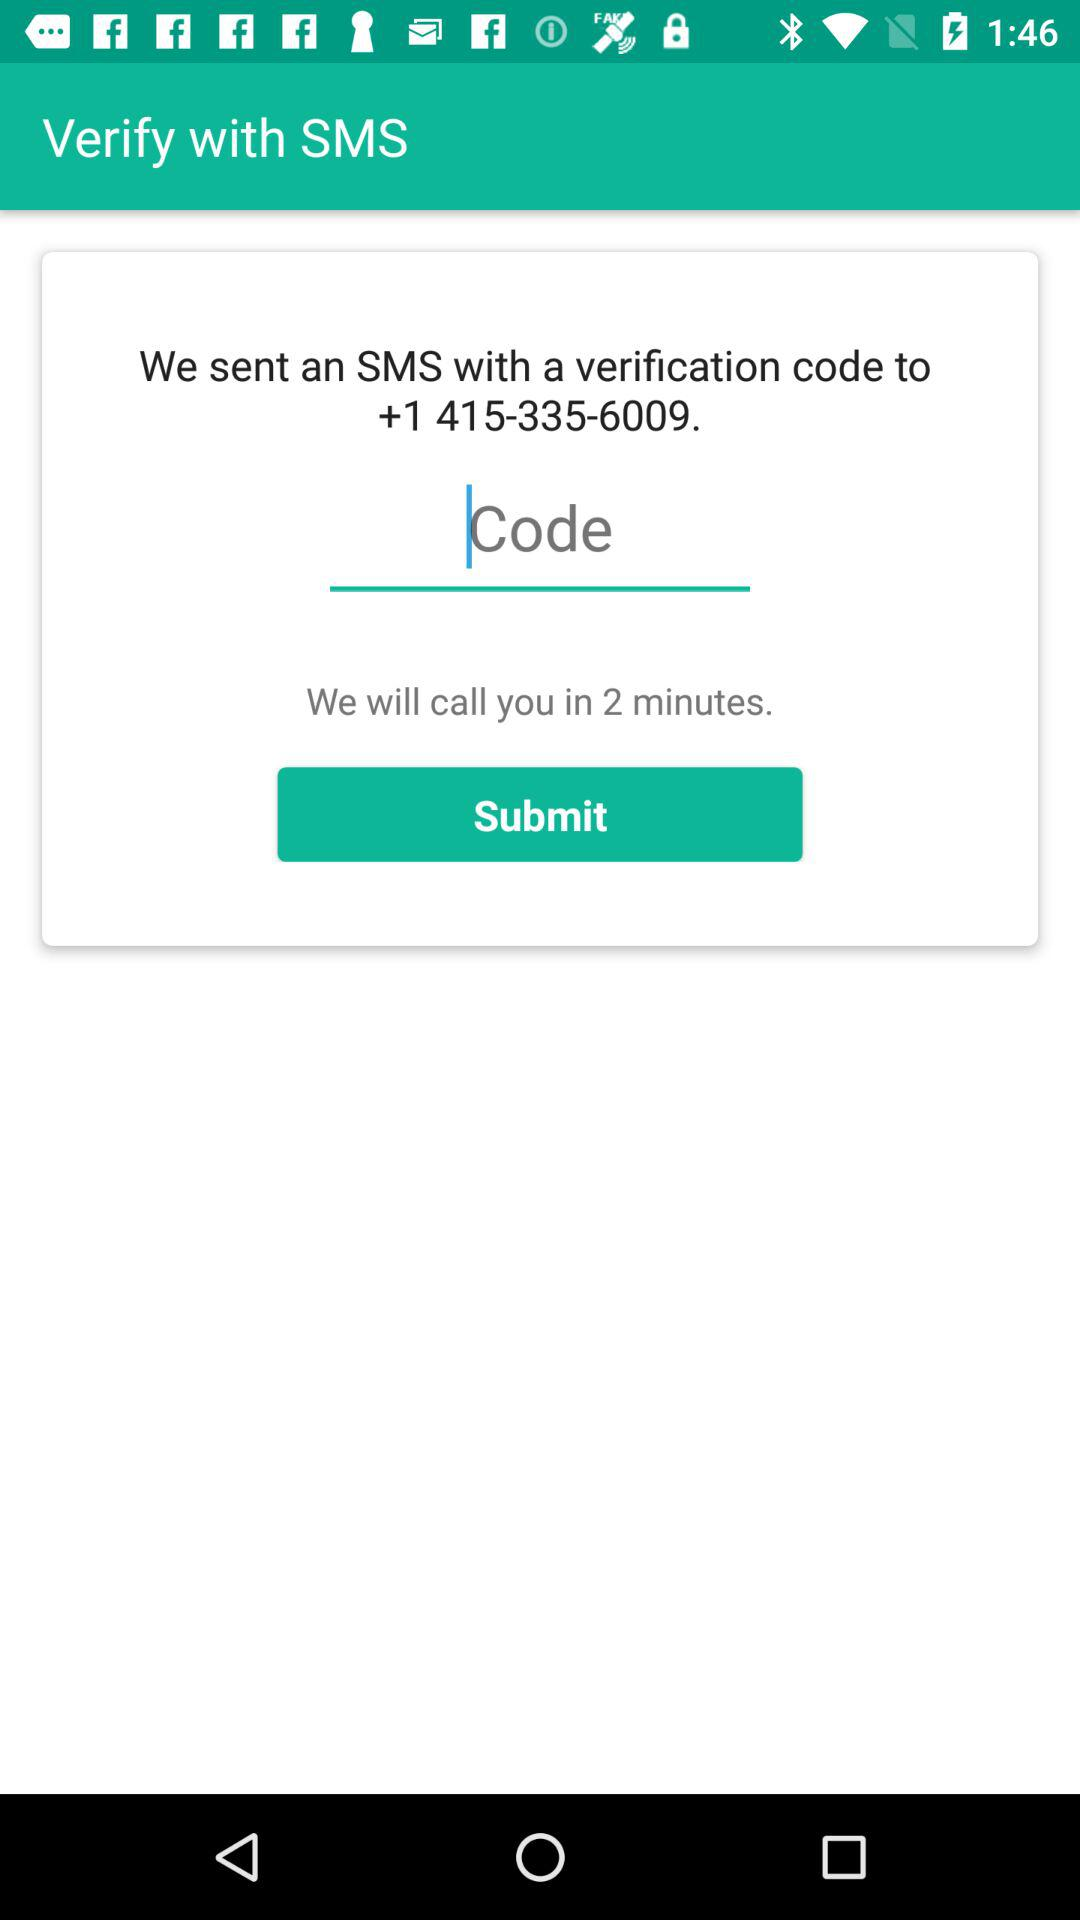How many minutes will it take for the call to be connected?
Answer the question using a single word or phrase. 2 